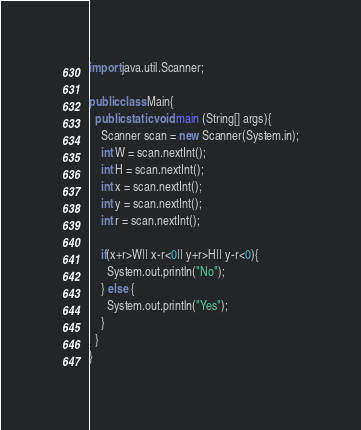<code> <loc_0><loc_0><loc_500><loc_500><_Java_>import java.util.Scanner;

public class Main{
  public static void main (String[] args){
    Scanner scan = new Scanner(System.in);
    int W = scan.nextInt();
    int H = scan.nextInt();
    int x = scan.nextInt();
    int y = scan.nextInt();
    int r = scan.nextInt();

    if(x+r>W|| x-r<0|| y+r>H|| y-r<0){
      System.out.println("No");
    } else {
      System.out.println("Yes");
    }
  }
}</code> 